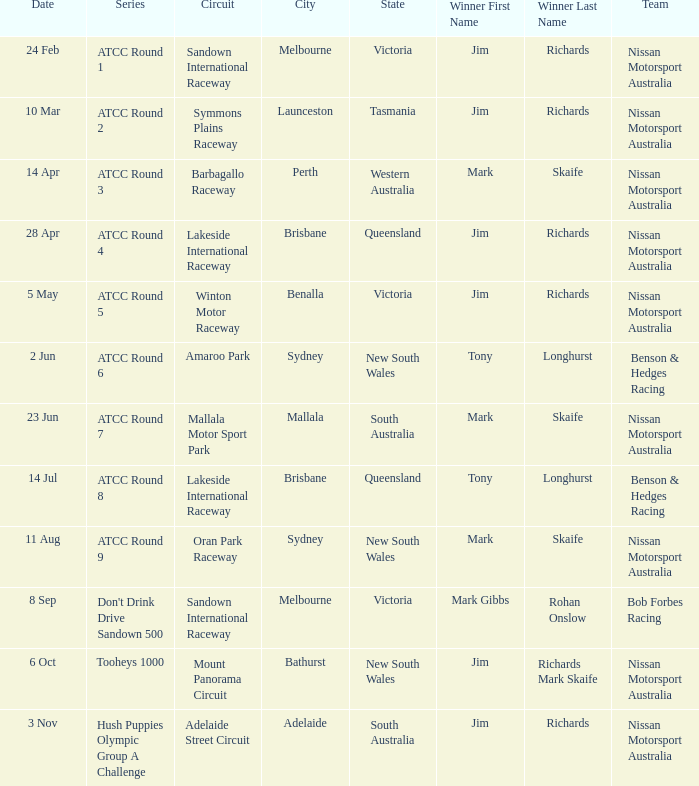What is the Circuit in the ATCC Round 1 Series with Winner Jim Richards? Sandown International Raceway. 